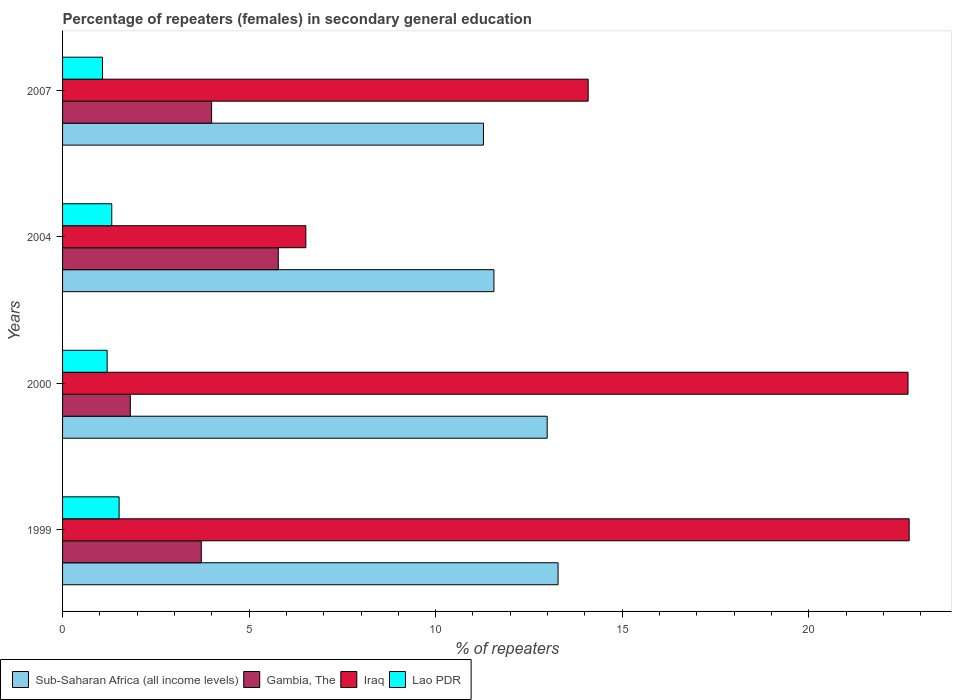How many different coloured bars are there?
Offer a terse response. 4. Are the number of bars per tick equal to the number of legend labels?
Ensure brevity in your answer.  Yes. How many bars are there on the 3rd tick from the top?
Provide a short and direct response. 4. How many bars are there on the 2nd tick from the bottom?
Offer a terse response. 4. In how many cases, is the number of bars for a given year not equal to the number of legend labels?
Provide a succinct answer. 0. What is the percentage of female repeaters in Sub-Saharan Africa (all income levels) in 1999?
Provide a succinct answer. 13.28. Across all years, what is the maximum percentage of female repeaters in Sub-Saharan Africa (all income levels)?
Give a very brief answer. 13.28. Across all years, what is the minimum percentage of female repeaters in Lao PDR?
Offer a very short reply. 1.07. In which year was the percentage of female repeaters in Lao PDR maximum?
Give a very brief answer. 1999. In which year was the percentage of female repeaters in Iraq minimum?
Your answer should be compact. 2004. What is the total percentage of female repeaters in Lao PDR in the graph?
Offer a terse response. 5.1. What is the difference between the percentage of female repeaters in Sub-Saharan Africa (all income levels) in 2000 and that in 2007?
Your answer should be compact. 1.71. What is the difference between the percentage of female repeaters in Sub-Saharan Africa (all income levels) in 2000 and the percentage of female repeaters in Iraq in 1999?
Give a very brief answer. -9.7. What is the average percentage of female repeaters in Lao PDR per year?
Give a very brief answer. 1.27. In the year 2000, what is the difference between the percentage of female repeaters in Iraq and percentage of female repeaters in Sub-Saharan Africa (all income levels)?
Make the answer very short. 9.67. In how many years, is the percentage of female repeaters in Iraq greater than 13 %?
Your answer should be compact. 3. What is the ratio of the percentage of female repeaters in Sub-Saharan Africa (all income levels) in 2000 to that in 2004?
Give a very brief answer. 1.12. What is the difference between the highest and the second highest percentage of female repeaters in Sub-Saharan Africa (all income levels)?
Make the answer very short. 0.29. What is the difference between the highest and the lowest percentage of female repeaters in Lao PDR?
Offer a terse response. 0.45. Is the sum of the percentage of female repeaters in Gambia, The in 1999 and 2007 greater than the maximum percentage of female repeaters in Lao PDR across all years?
Your answer should be very brief. Yes. Is it the case that in every year, the sum of the percentage of female repeaters in Iraq and percentage of female repeaters in Gambia, The is greater than the sum of percentage of female repeaters in Sub-Saharan Africa (all income levels) and percentage of female repeaters in Lao PDR?
Offer a very short reply. No. What does the 2nd bar from the top in 1999 represents?
Provide a succinct answer. Iraq. What does the 3rd bar from the bottom in 1999 represents?
Your answer should be very brief. Iraq. How many bars are there?
Your answer should be compact. 16. Are all the bars in the graph horizontal?
Your response must be concise. Yes. What is the difference between two consecutive major ticks on the X-axis?
Provide a short and direct response. 5. Does the graph contain any zero values?
Keep it short and to the point. No. Does the graph contain grids?
Make the answer very short. No. Where does the legend appear in the graph?
Make the answer very short. Bottom left. What is the title of the graph?
Offer a very short reply. Percentage of repeaters (females) in secondary general education. Does "Sub-Saharan Africa (developing only)" appear as one of the legend labels in the graph?
Give a very brief answer. No. What is the label or title of the X-axis?
Offer a very short reply. % of repeaters. What is the label or title of the Y-axis?
Give a very brief answer. Years. What is the % of repeaters of Sub-Saharan Africa (all income levels) in 1999?
Your answer should be compact. 13.28. What is the % of repeaters in Gambia, The in 1999?
Your answer should be very brief. 3.72. What is the % of repeaters of Iraq in 1999?
Your answer should be compact. 22.69. What is the % of repeaters of Lao PDR in 1999?
Your response must be concise. 1.52. What is the % of repeaters in Sub-Saharan Africa (all income levels) in 2000?
Provide a succinct answer. 12.99. What is the % of repeaters of Gambia, The in 2000?
Offer a very short reply. 1.82. What is the % of repeaters of Iraq in 2000?
Provide a short and direct response. 22.66. What is the % of repeaters in Lao PDR in 2000?
Give a very brief answer. 1.2. What is the % of repeaters in Sub-Saharan Africa (all income levels) in 2004?
Ensure brevity in your answer.  11.56. What is the % of repeaters in Gambia, The in 2004?
Offer a very short reply. 5.78. What is the % of repeaters in Iraq in 2004?
Offer a very short reply. 6.52. What is the % of repeaters of Lao PDR in 2004?
Your answer should be compact. 1.32. What is the % of repeaters in Sub-Saharan Africa (all income levels) in 2007?
Offer a terse response. 11.28. What is the % of repeaters in Gambia, The in 2007?
Give a very brief answer. 3.99. What is the % of repeaters of Iraq in 2007?
Provide a succinct answer. 14.09. What is the % of repeaters of Lao PDR in 2007?
Provide a short and direct response. 1.07. Across all years, what is the maximum % of repeaters in Sub-Saharan Africa (all income levels)?
Your response must be concise. 13.28. Across all years, what is the maximum % of repeaters in Gambia, The?
Offer a terse response. 5.78. Across all years, what is the maximum % of repeaters of Iraq?
Your answer should be very brief. 22.69. Across all years, what is the maximum % of repeaters in Lao PDR?
Your answer should be very brief. 1.52. Across all years, what is the minimum % of repeaters in Sub-Saharan Africa (all income levels)?
Provide a short and direct response. 11.28. Across all years, what is the minimum % of repeaters of Gambia, The?
Provide a succinct answer. 1.82. Across all years, what is the minimum % of repeaters of Iraq?
Ensure brevity in your answer.  6.52. Across all years, what is the minimum % of repeaters in Lao PDR?
Your response must be concise. 1.07. What is the total % of repeaters of Sub-Saharan Africa (all income levels) in the graph?
Your answer should be compact. 49.11. What is the total % of repeaters in Gambia, The in the graph?
Ensure brevity in your answer.  15.31. What is the total % of repeaters in Iraq in the graph?
Give a very brief answer. 65.96. What is the total % of repeaters of Lao PDR in the graph?
Your answer should be compact. 5.1. What is the difference between the % of repeaters of Sub-Saharan Africa (all income levels) in 1999 and that in 2000?
Give a very brief answer. 0.29. What is the difference between the % of repeaters of Gambia, The in 1999 and that in 2000?
Provide a short and direct response. 1.9. What is the difference between the % of repeaters in Iraq in 1999 and that in 2000?
Ensure brevity in your answer.  0.03. What is the difference between the % of repeaters in Lao PDR in 1999 and that in 2000?
Your response must be concise. 0.32. What is the difference between the % of repeaters in Sub-Saharan Africa (all income levels) in 1999 and that in 2004?
Ensure brevity in your answer.  1.72. What is the difference between the % of repeaters in Gambia, The in 1999 and that in 2004?
Offer a terse response. -2.06. What is the difference between the % of repeaters in Iraq in 1999 and that in 2004?
Your response must be concise. 16.17. What is the difference between the % of repeaters of Lao PDR in 1999 and that in 2004?
Provide a short and direct response. 0.2. What is the difference between the % of repeaters in Sub-Saharan Africa (all income levels) in 1999 and that in 2007?
Your answer should be very brief. 2. What is the difference between the % of repeaters of Gambia, The in 1999 and that in 2007?
Your answer should be very brief. -0.28. What is the difference between the % of repeaters of Iraq in 1999 and that in 2007?
Your answer should be compact. 8.6. What is the difference between the % of repeaters in Lao PDR in 1999 and that in 2007?
Your answer should be very brief. 0.45. What is the difference between the % of repeaters in Sub-Saharan Africa (all income levels) in 2000 and that in 2004?
Keep it short and to the point. 1.43. What is the difference between the % of repeaters in Gambia, The in 2000 and that in 2004?
Your response must be concise. -3.97. What is the difference between the % of repeaters in Iraq in 2000 and that in 2004?
Give a very brief answer. 16.14. What is the difference between the % of repeaters in Lao PDR in 2000 and that in 2004?
Keep it short and to the point. -0.12. What is the difference between the % of repeaters in Sub-Saharan Africa (all income levels) in 2000 and that in 2007?
Provide a short and direct response. 1.71. What is the difference between the % of repeaters of Gambia, The in 2000 and that in 2007?
Provide a succinct answer. -2.18. What is the difference between the % of repeaters in Iraq in 2000 and that in 2007?
Your answer should be compact. 8.57. What is the difference between the % of repeaters of Lao PDR in 2000 and that in 2007?
Offer a very short reply. 0.13. What is the difference between the % of repeaters of Sub-Saharan Africa (all income levels) in 2004 and that in 2007?
Keep it short and to the point. 0.28. What is the difference between the % of repeaters of Gambia, The in 2004 and that in 2007?
Give a very brief answer. 1.79. What is the difference between the % of repeaters in Iraq in 2004 and that in 2007?
Your answer should be compact. -7.57. What is the difference between the % of repeaters in Lao PDR in 2004 and that in 2007?
Give a very brief answer. 0.25. What is the difference between the % of repeaters in Sub-Saharan Africa (all income levels) in 1999 and the % of repeaters in Gambia, The in 2000?
Keep it short and to the point. 11.46. What is the difference between the % of repeaters in Sub-Saharan Africa (all income levels) in 1999 and the % of repeaters in Iraq in 2000?
Your response must be concise. -9.38. What is the difference between the % of repeaters of Sub-Saharan Africa (all income levels) in 1999 and the % of repeaters of Lao PDR in 2000?
Make the answer very short. 12.09. What is the difference between the % of repeaters of Gambia, The in 1999 and the % of repeaters of Iraq in 2000?
Your response must be concise. -18.94. What is the difference between the % of repeaters in Gambia, The in 1999 and the % of repeaters in Lao PDR in 2000?
Your answer should be very brief. 2.52. What is the difference between the % of repeaters in Iraq in 1999 and the % of repeaters in Lao PDR in 2000?
Keep it short and to the point. 21.5. What is the difference between the % of repeaters in Sub-Saharan Africa (all income levels) in 1999 and the % of repeaters in Gambia, The in 2004?
Make the answer very short. 7.5. What is the difference between the % of repeaters of Sub-Saharan Africa (all income levels) in 1999 and the % of repeaters of Iraq in 2004?
Offer a very short reply. 6.76. What is the difference between the % of repeaters of Sub-Saharan Africa (all income levels) in 1999 and the % of repeaters of Lao PDR in 2004?
Provide a succinct answer. 11.96. What is the difference between the % of repeaters of Gambia, The in 1999 and the % of repeaters of Iraq in 2004?
Give a very brief answer. -2.8. What is the difference between the % of repeaters in Gambia, The in 1999 and the % of repeaters in Lao PDR in 2004?
Ensure brevity in your answer.  2.4. What is the difference between the % of repeaters of Iraq in 1999 and the % of repeaters of Lao PDR in 2004?
Your answer should be very brief. 21.37. What is the difference between the % of repeaters of Sub-Saharan Africa (all income levels) in 1999 and the % of repeaters of Gambia, The in 2007?
Give a very brief answer. 9.29. What is the difference between the % of repeaters in Sub-Saharan Africa (all income levels) in 1999 and the % of repeaters in Iraq in 2007?
Offer a very short reply. -0.81. What is the difference between the % of repeaters of Sub-Saharan Africa (all income levels) in 1999 and the % of repeaters of Lao PDR in 2007?
Provide a short and direct response. 12.21. What is the difference between the % of repeaters in Gambia, The in 1999 and the % of repeaters in Iraq in 2007?
Offer a terse response. -10.37. What is the difference between the % of repeaters in Gambia, The in 1999 and the % of repeaters in Lao PDR in 2007?
Give a very brief answer. 2.65. What is the difference between the % of repeaters of Iraq in 1999 and the % of repeaters of Lao PDR in 2007?
Provide a succinct answer. 21.62. What is the difference between the % of repeaters in Sub-Saharan Africa (all income levels) in 2000 and the % of repeaters in Gambia, The in 2004?
Keep it short and to the point. 7.21. What is the difference between the % of repeaters in Sub-Saharan Africa (all income levels) in 2000 and the % of repeaters in Iraq in 2004?
Provide a succinct answer. 6.47. What is the difference between the % of repeaters of Sub-Saharan Africa (all income levels) in 2000 and the % of repeaters of Lao PDR in 2004?
Give a very brief answer. 11.67. What is the difference between the % of repeaters in Gambia, The in 2000 and the % of repeaters in Iraq in 2004?
Offer a terse response. -4.7. What is the difference between the % of repeaters in Gambia, The in 2000 and the % of repeaters in Lao PDR in 2004?
Make the answer very short. 0.5. What is the difference between the % of repeaters of Iraq in 2000 and the % of repeaters of Lao PDR in 2004?
Provide a succinct answer. 21.34. What is the difference between the % of repeaters of Sub-Saharan Africa (all income levels) in 2000 and the % of repeaters of Gambia, The in 2007?
Make the answer very short. 8.99. What is the difference between the % of repeaters in Sub-Saharan Africa (all income levels) in 2000 and the % of repeaters in Iraq in 2007?
Provide a succinct answer. -1.1. What is the difference between the % of repeaters in Sub-Saharan Africa (all income levels) in 2000 and the % of repeaters in Lao PDR in 2007?
Give a very brief answer. 11.92. What is the difference between the % of repeaters of Gambia, The in 2000 and the % of repeaters of Iraq in 2007?
Give a very brief answer. -12.27. What is the difference between the % of repeaters in Gambia, The in 2000 and the % of repeaters in Lao PDR in 2007?
Your answer should be compact. 0.75. What is the difference between the % of repeaters in Iraq in 2000 and the % of repeaters in Lao PDR in 2007?
Your answer should be very brief. 21.59. What is the difference between the % of repeaters of Sub-Saharan Africa (all income levels) in 2004 and the % of repeaters of Gambia, The in 2007?
Offer a very short reply. 7.57. What is the difference between the % of repeaters of Sub-Saharan Africa (all income levels) in 2004 and the % of repeaters of Iraq in 2007?
Your response must be concise. -2.53. What is the difference between the % of repeaters of Sub-Saharan Africa (all income levels) in 2004 and the % of repeaters of Lao PDR in 2007?
Offer a terse response. 10.49. What is the difference between the % of repeaters of Gambia, The in 2004 and the % of repeaters of Iraq in 2007?
Your response must be concise. -8.31. What is the difference between the % of repeaters of Gambia, The in 2004 and the % of repeaters of Lao PDR in 2007?
Provide a short and direct response. 4.71. What is the difference between the % of repeaters in Iraq in 2004 and the % of repeaters in Lao PDR in 2007?
Offer a very short reply. 5.45. What is the average % of repeaters in Sub-Saharan Africa (all income levels) per year?
Your response must be concise. 12.28. What is the average % of repeaters in Gambia, The per year?
Make the answer very short. 3.83. What is the average % of repeaters of Iraq per year?
Make the answer very short. 16.49. What is the average % of repeaters of Lao PDR per year?
Offer a very short reply. 1.27. In the year 1999, what is the difference between the % of repeaters in Sub-Saharan Africa (all income levels) and % of repeaters in Gambia, The?
Give a very brief answer. 9.56. In the year 1999, what is the difference between the % of repeaters of Sub-Saharan Africa (all income levels) and % of repeaters of Iraq?
Your answer should be very brief. -9.41. In the year 1999, what is the difference between the % of repeaters of Sub-Saharan Africa (all income levels) and % of repeaters of Lao PDR?
Ensure brevity in your answer.  11.77. In the year 1999, what is the difference between the % of repeaters in Gambia, The and % of repeaters in Iraq?
Your answer should be compact. -18.97. In the year 1999, what is the difference between the % of repeaters of Gambia, The and % of repeaters of Lao PDR?
Provide a succinct answer. 2.2. In the year 1999, what is the difference between the % of repeaters of Iraq and % of repeaters of Lao PDR?
Offer a very short reply. 21.18. In the year 2000, what is the difference between the % of repeaters in Sub-Saharan Africa (all income levels) and % of repeaters in Gambia, The?
Your answer should be very brief. 11.17. In the year 2000, what is the difference between the % of repeaters of Sub-Saharan Africa (all income levels) and % of repeaters of Iraq?
Ensure brevity in your answer.  -9.67. In the year 2000, what is the difference between the % of repeaters of Sub-Saharan Africa (all income levels) and % of repeaters of Lao PDR?
Your answer should be very brief. 11.79. In the year 2000, what is the difference between the % of repeaters in Gambia, The and % of repeaters in Iraq?
Your answer should be compact. -20.84. In the year 2000, what is the difference between the % of repeaters of Gambia, The and % of repeaters of Lao PDR?
Offer a terse response. 0.62. In the year 2000, what is the difference between the % of repeaters of Iraq and % of repeaters of Lao PDR?
Ensure brevity in your answer.  21.46. In the year 2004, what is the difference between the % of repeaters of Sub-Saharan Africa (all income levels) and % of repeaters of Gambia, The?
Provide a short and direct response. 5.78. In the year 2004, what is the difference between the % of repeaters in Sub-Saharan Africa (all income levels) and % of repeaters in Iraq?
Offer a terse response. 5.04. In the year 2004, what is the difference between the % of repeaters of Sub-Saharan Africa (all income levels) and % of repeaters of Lao PDR?
Offer a very short reply. 10.24. In the year 2004, what is the difference between the % of repeaters in Gambia, The and % of repeaters in Iraq?
Your answer should be very brief. -0.74. In the year 2004, what is the difference between the % of repeaters in Gambia, The and % of repeaters in Lao PDR?
Provide a short and direct response. 4.46. In the year 2004, what is the difference between the % of repeaters of Iraq and % of repeaters of Lao PDR?
Your response must be concise. 5.2. In the year 2007, what is the difference between the % of repeaters in Sub-Saharan Africa (all income levels) and % of repeaters in Gambia, The?
Provide a short and direct response. 7.29. In the year 2007, what is the difference between the % of repeaters of Sub-Saharan Africa (all income levels) and % of repeaters of Iraq?
Your answer should be very brief. -2.81. In the year 2007, what is the difference between the % of repeaters of Sub-Saharan Africa (all income levels) and % of repeaters of Lao PDR?
Provide a short and direct response. 10.21. In the year 2007, what is the difference between the % of repeaters of Gambia, The and % of repeaters of Iraq?
Keep it short and to the point. -10.09. In the year 2007, what is the difference between the % of repeaters in Gambia, The and % of repeaters in Lao PDR?
Provide a succinct answer. 2.92. In the year 2007, what is the difference between the % of repeaters in Iraq and % of repeaters in Lao PDR?
Give a very brief answer. 13.02. What is the ratio of the % of repeaters of Sub-Saharan Africa (all income levels) in 1999 to that in 2000?
Keep it short and to the point. 1.02. What is the ratio of the % of repeaters of Gambia, The in 1999 to that in 2000?
Offer a very short reply. 2.05. What is the ratio of the % of repeaters in Iraq in 1999 to that in 2000?
Your response must be concise. 1. What is the ratio of the % of repeaters of Lao PDR in 1999 to that in 2000?
Your answer should be very brief. 1.27. What is the ratio of the % of repeaters of Sub-Saharan Africa (all income levels) in 1999 to that in 2004?
Keep it short and to the point. 1.15. What is the ratio of the % of repeaters in Gambia, The in 1999 to that in 2004?
Offer a terse response. 0.64. What is the ratio of the % of repeaters in Iraq in 1999 to that in 2004?
Provide a succinct answer. 3.48. What is the ratio of the % of repeaters of Lao PDR in 1999 to that in 2004?
Your response must be concise. 1.15. What is the ratio of the % of repeaters in Sub-Saharan Africa (all income levels) in 1999 to that in 2007?
Ensure brevity in your answer.  1.18. What is the ratio of the % of repeaters of Gambia, The in 1999 to that in 2007?
Provide a succinct answer. 0.93. What is the ratio of the % of repeaters of Iraq in 1999 to that in 2007?
Your answer should be compact. 1.61. What is the ratio of the % of repeaters of Lao PDR in 1999 to that in 2007?
Provide a succinct answer. 1.42. What is the ratio of the % of repeaters in Sub-Saharan Africa (all income levels) in 2000 to that in 2004?
Offer a very short reply. 1.12. What is the ratio of the % of repeaters of Gambia, The in 2000 to that in 2004?
Make the answer very short. 0.31. What is the ratio of the % of repeaters of Iraq in 2000 to that in 2004?
Make the answer very short. 3.48. What is the ratio of the % of repeaters in Lao PDR in 2000 to that in 2004?
Your answer should be compact. 0.91. What is the ratio of the % of repeaters in Sub-Saharan Africa (all income levels) in 2000 to that in 2007?
Offer a terse response. 1.15. What is the ratio of the % of repeaters of Gambia, The in 2000 to that in 2007?
Your answer should be very brief. 0.45. What is the ratio of the % of repeaters of Iraq in 2000 to that in 2007?
Keep it short and to the point. 1.61. What is the ratio of the % of repeaters of Lao PDR in 2000 to that in 2007?
Your answer should be compact. 1.12. What is the ratio of the % of repeaters in Sub-Saharan Africa (all income levels) in 2004 to that in 2007?
Offer a terse response. 1.02. What is the ratio of the % of repeaters in Gambia, The in 2004 to that in 2007?
Provide a short and direct response. 1.45. What is the ratio of the % of repeaters of Iraq in 2004 to that in 2007?
Ensure brevity in your answer.  0.46. What is the ratio of the % of repeaters in Lao PDR in 2004 to that in 2007?
Make the answer very short. 1.23. What is the difference between the highest and the second highest % of repeaters of Sub-Saharan Africa (all income levels)?
Ensure brevity in your answer.  0.29. What is the difference between the highest and the second highest % of repeaters of Gambia, The?
Make the answer very short. 1.79. What is the difference between the highest and the second highest % of repeaters in Iraq?
Offer a very short reply. 0.03. What is the difference between the highest and the second highest % of repeaters of Lao PDR?
Make the answer very short. 0.2. What is the difference between the highest and the lowest % of repeaters in Sub-Saharan Africa (all income levels)?
Offer a very short reply. 2. What is the difference between the highest and the lowest % of repeaters of Gambia, The?
Keep it short and to the point. 3.97. What is the difference between the highest and the lowest % of repeaters in Iraq?
Your answer should be compact. 16.17. What is the difference between the highest and the lowest % of repeaters of Lao PDR?
Your answer should be compact. 0.45. 